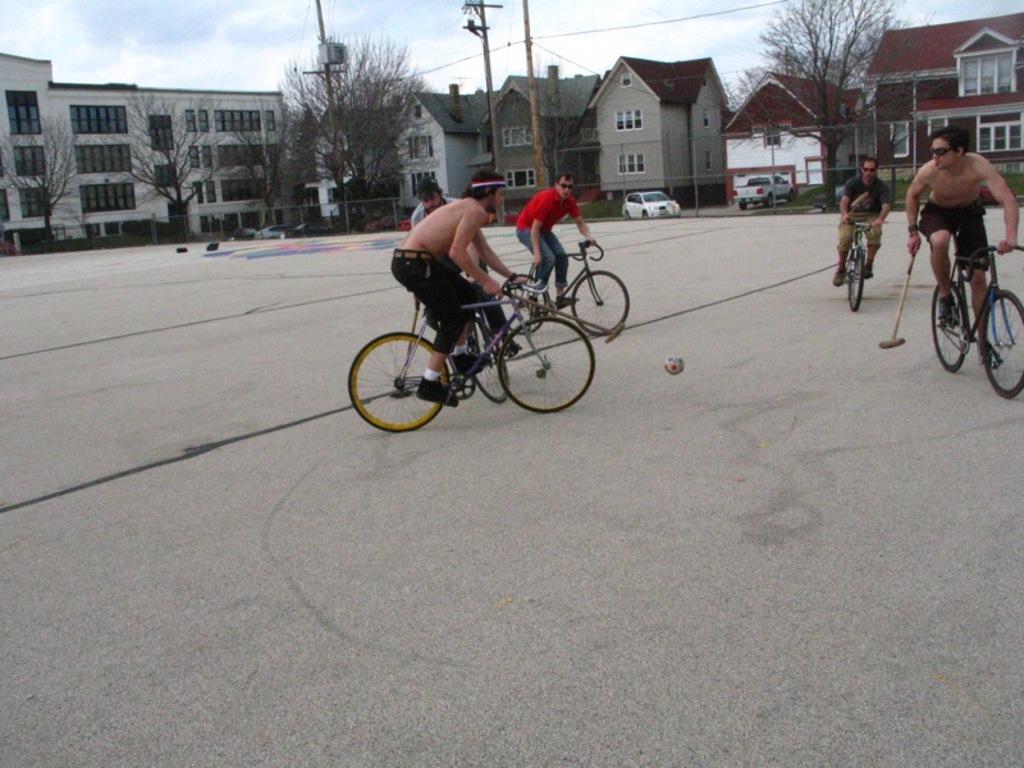Describe this image in one or two sentences. In this image there are group of persons riding the bicycle by kicking the ball with the bat and at the back ground there are building, tree, pole , car, house. 